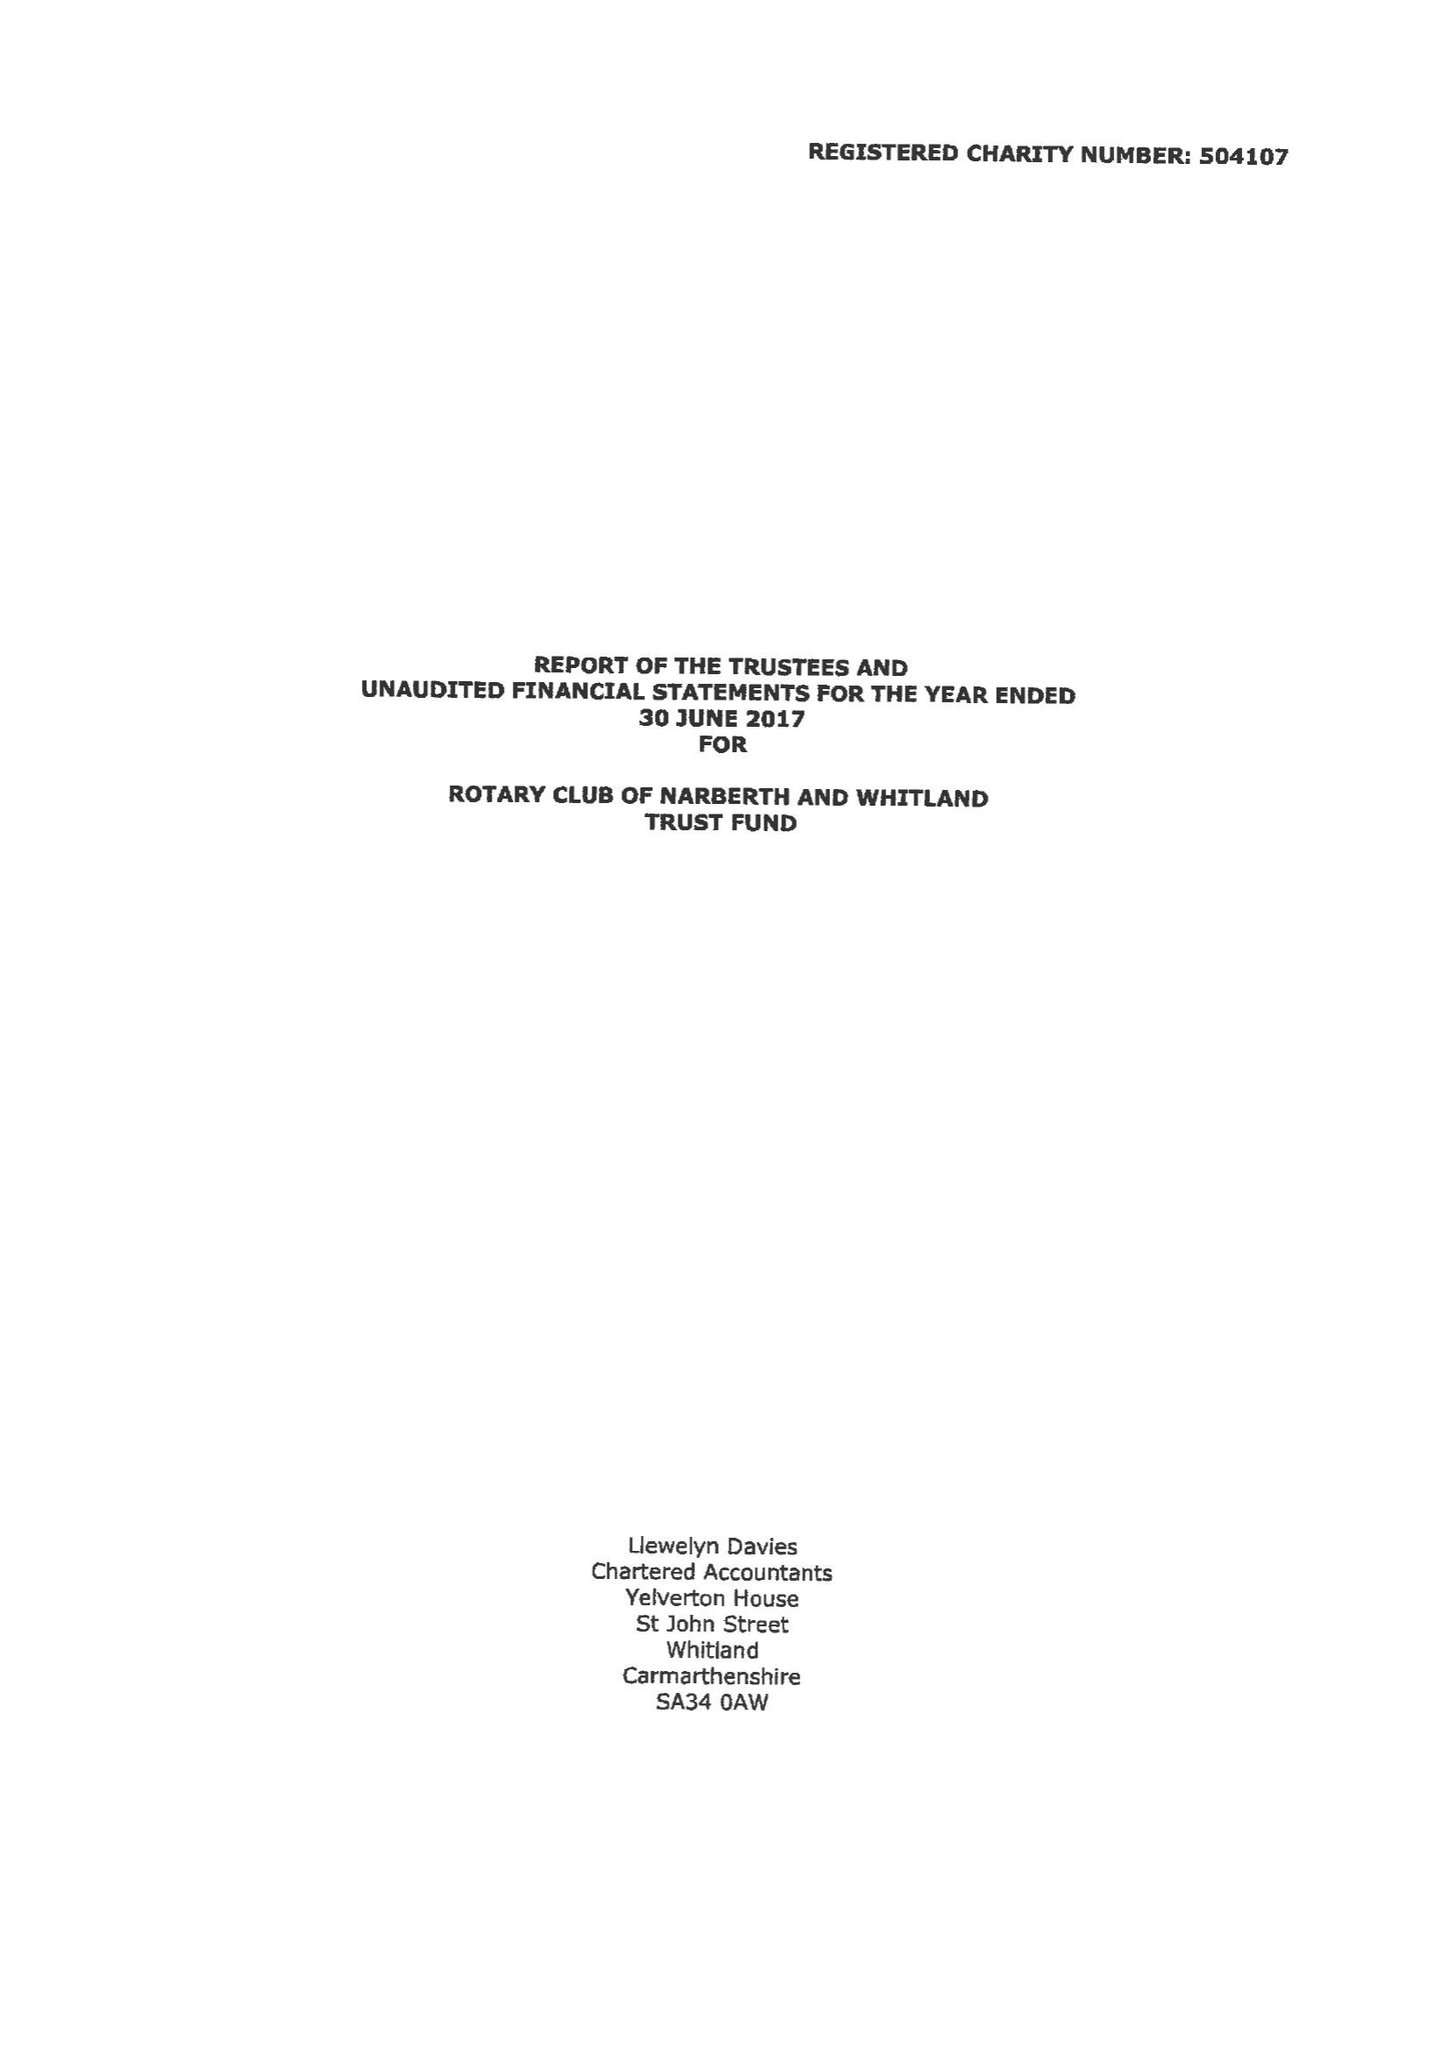What is the value for the address__post_town?
Answer the question using a single word or phrase. NARBERTH 